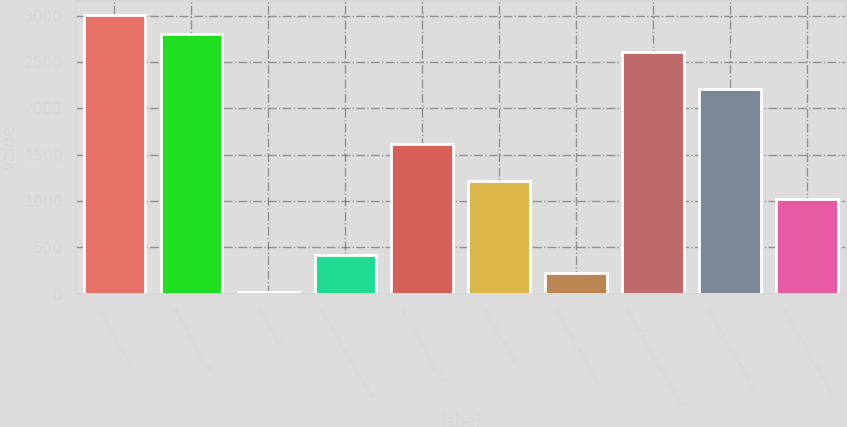Convert chart to OTSL. <chart><loc_0><loc_0><loc_500><loc_500><bar_chart><fcel>(Millions of Dollars)<fcel>Benefit obligation at<fcel>Service cost<fcel>Interest cost on accumulated<fcel>Net actuarial loss/(gain)<fcel>Benefits paid and<fcel>Participant contributions<fcel>BENEFIT OBLIGATION AT END OF<fcel>Fair value of plan assets at<fcel>Actual return on plan assets<nl><fcel>3007.5<fcel>2808.4<fcel>21<fcel>419.2<fcel>1613.8<fcel>1215.6<fcel>220.1<fcel>2609.3<fcel>2211.1<fcel>1016.5<nl></chart> 